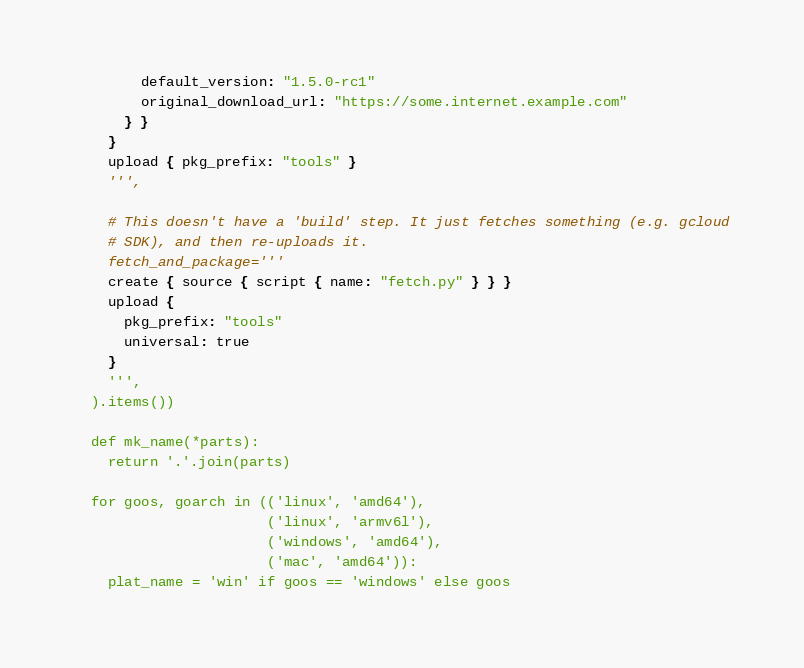<code> <loc_0><loc_0><loc_500><loc_500><_Python_>        default_version: "1.5.0-rc1"
        original_download_url: "https://some.internet.example.com"
      } }
    }
    upload { pkg_prefix: "tools" }
    ''',

    # This doesn't have a 'build' step. It just fetches something (e.g. gcloud
    # SDK), and then re-uploads it.
    fetch_and_package='''
    create { source { script { name: "fetch.py" } } }
    upload {
      pkg_prefix: "tools"
      universal: true
    }
    ''',
  ).items())

  def mk_name(*parts):
    return '.'.join(parts)

  for goos, goarch in (('linux', 'amd64'),
                       ('linux', 'armv6l'),
                       ('windows', 'amd64'),
                       ('mac', 'amd64')):
    plat_name = 'win' if goos == 'windows' else goos
</code> 